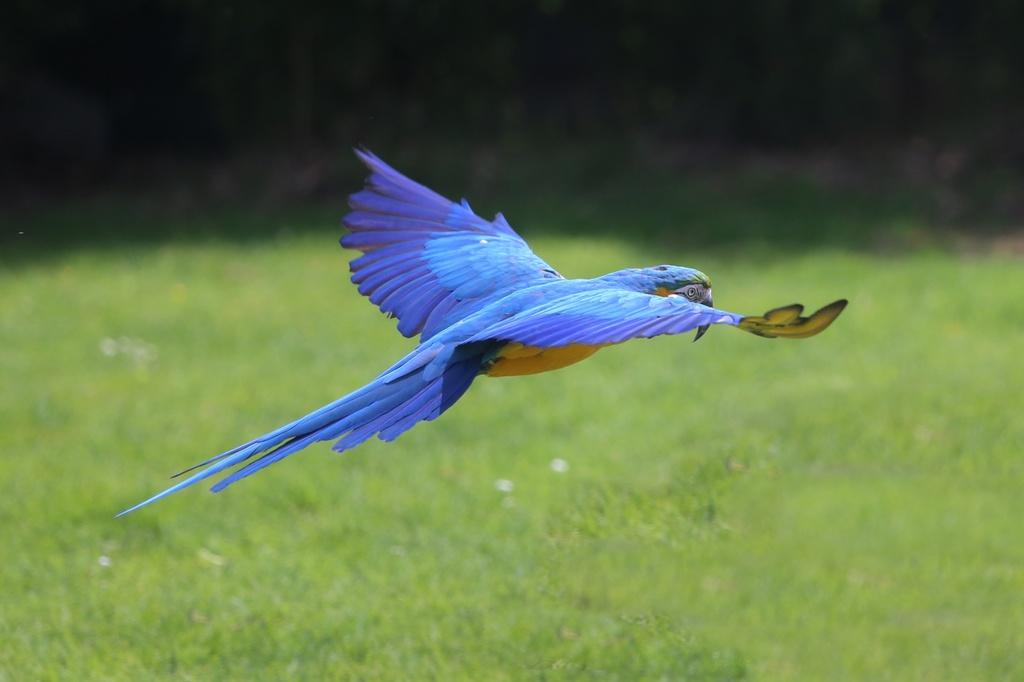What type of bird can be seen in the image? There is a blue color bird in the image. What type of vegetation is visible in the image? There is grass visible in the image. What is the color of the background in the image? The background of the image is dark. What language is the bird speaking in the image? Birds do not speak human languages, so it is not possible to determine what language the bird might be speaking in the image. 